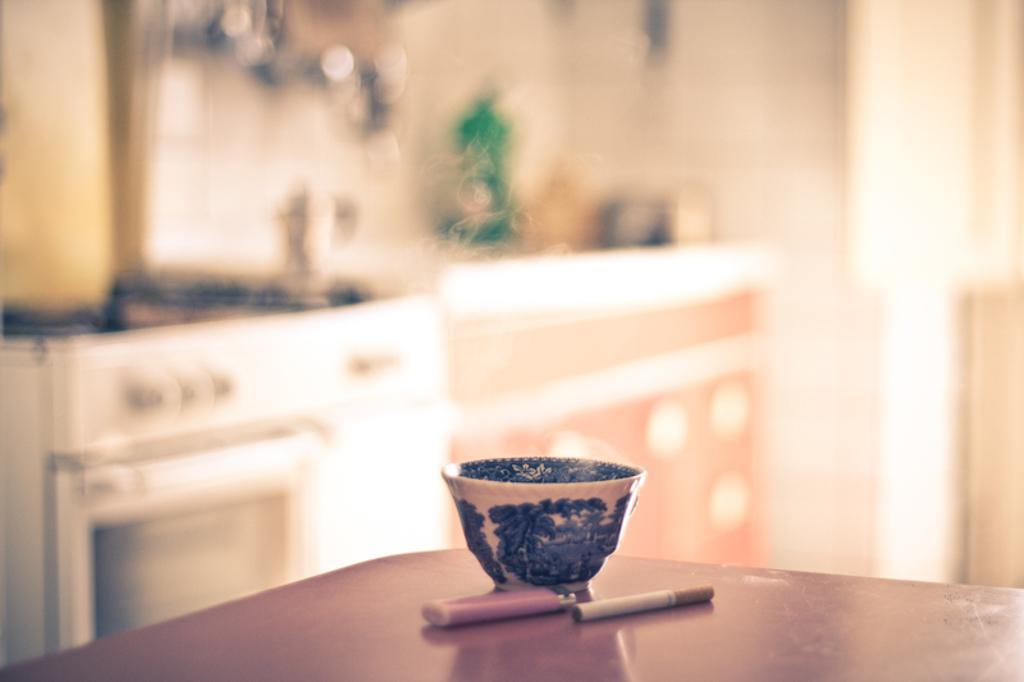Where was the image taken? The image was taken in a room. What furniture is present in the room? There is a table in the room. What is on the table? There is a bowl and a lighter on the table. What else is on the table? There is a cigarette on the table. What color is the background wall in the room? The background wall is blue. Can you tell me how many dinosaurs are in the room? There are no dinosaurs present in the room; the image only shows a table, a bowl, a lighter, and a cigarette. 